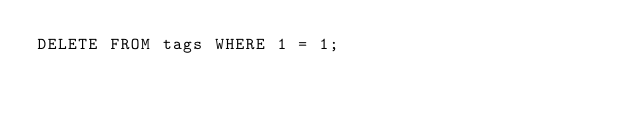Convert code to text. <code><loc_0><loc_0><loc_500><loc_500><_SQL_>DELETE FROM tags WHERE 1 = 1;
</code> 